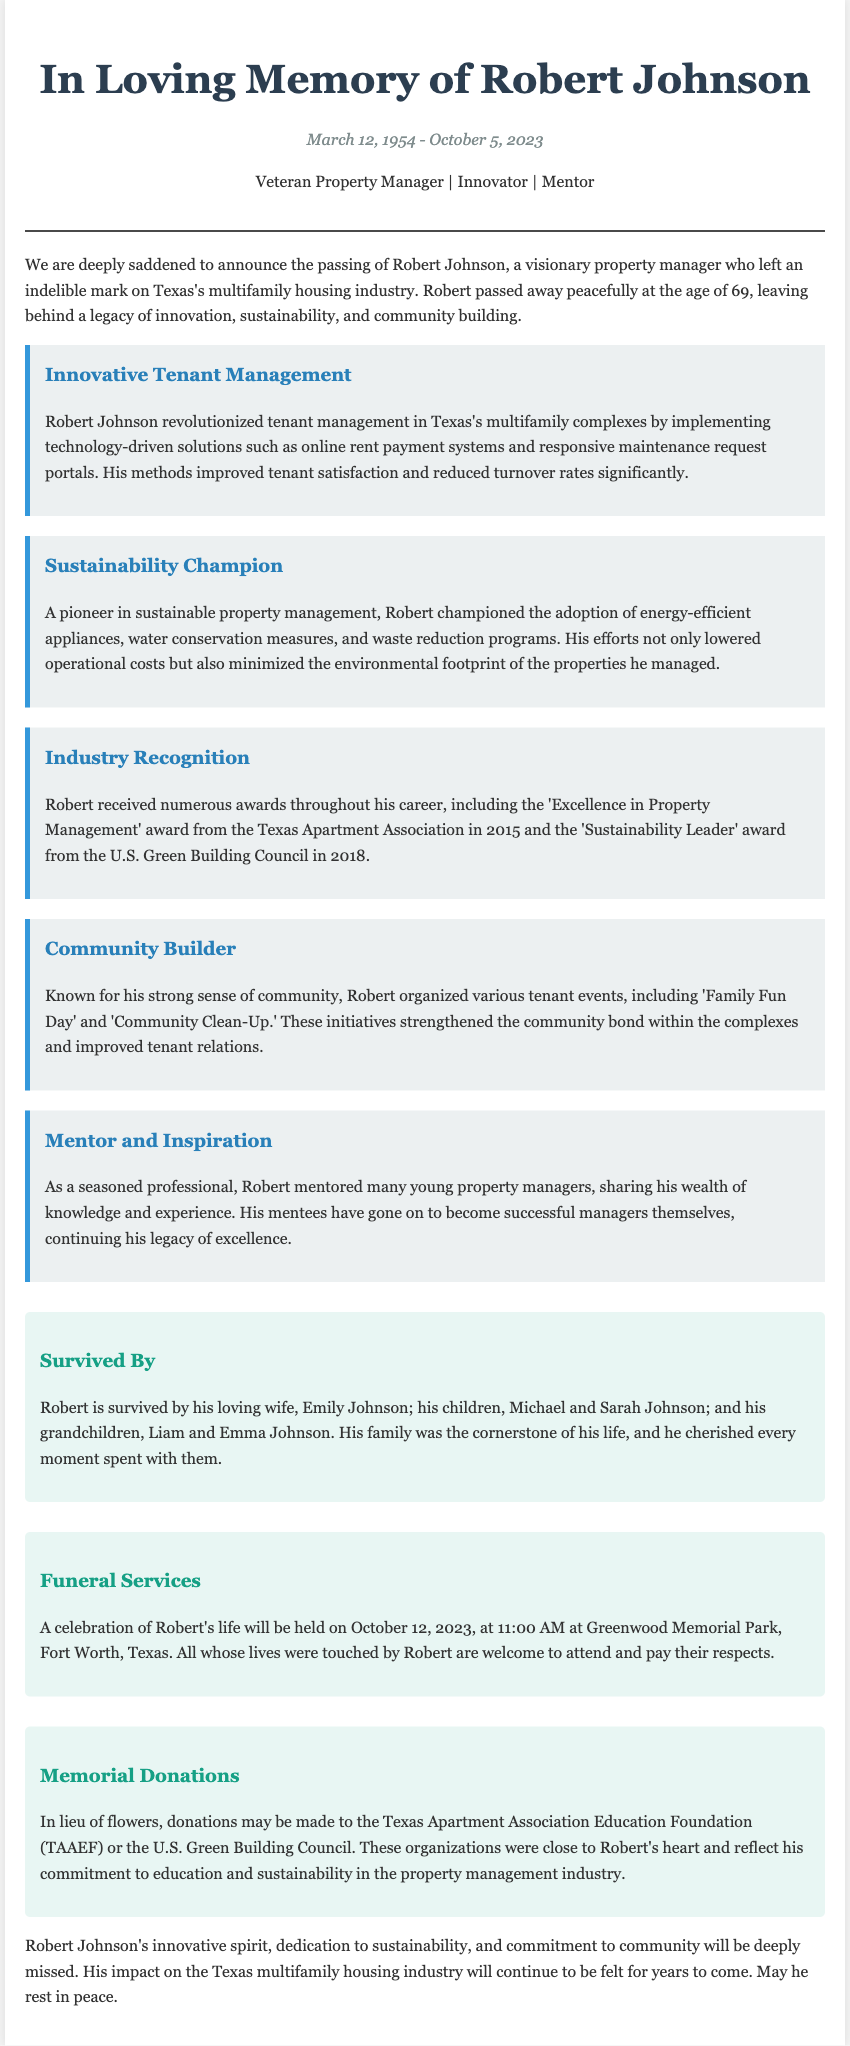What date did Robert Johnson pass away? The document states that Robert Johnson passed away on October 5, 2023.
Answer: October 5, 2023 What award did Robert receive in 2015? According to the document, Robert received the 'Excellence in Property Management' award from the Texas Apartment Association in 2015.
Answer: Excellence in Property Management Who is Robert's wife? The document mentions that Robert is survived by his loving wife, Emily Johnson.
Answer: Emily Johnson What was one of the tenant events organized by Robert? The document highlights 'Family Fun Day' as one of the tenant events organized by Robert.
Answer: Family Fun Day What is the date of Robert's celebration of life? The document specifies that the celebration of Robert's life will be held on October 12, 2023.
Answer: October 12, 2023 Why is Robert considered a sustainability champion? The document describes Robert as a sustainability champion for advocating energy-efficient appliances, water conservation measures, and waste reduction programs.
Answer: Energy-efficient appliances Who did Robert mentor? The document states that Robert mentored many young property managers.
Answer: Young property managers What organization can memorial donations be made to? According to the document, memorial donations may be made to the Texas Apartment Association Education Foundation (TAAEF).
Answer: Texas Apartment Association Education Foundation How old was Robert at the time of his passing? The document indicates Robert passed away at the age of 69.
Answer: 69 